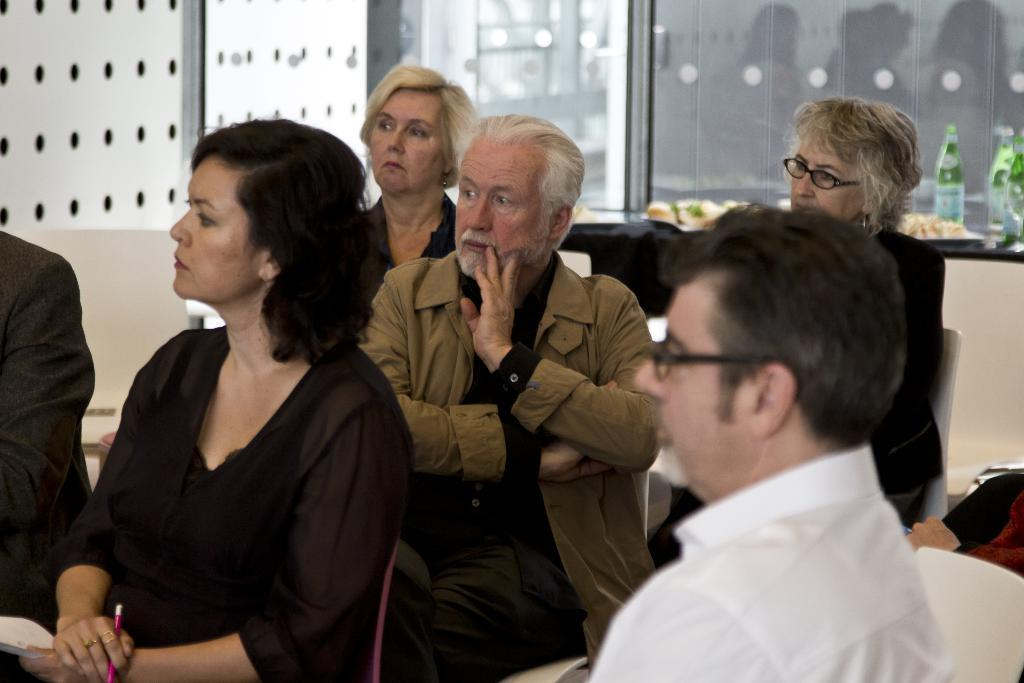What is happening in the room in the image? There are people sitting in the room. Can you describe the clothing of one of the people in the image? A person is wearing a white shirt on the right side. What type of objects can be seen in the image? There are glass bottles and food items in the image. What type of wheel can be seen on the ground in the image? There is no wheel or ground visible in the image; it features people sitting in a room. How many robins are perched on the food items in the image? There are no robins present in the image; it only shows people sitting and glass bottles. 